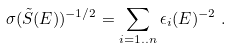Convert formula to latex. <formula><loc_0><loc_0><loc_500><loc_500>\sigma ( \tilde { S } ( E ) ) ^ { - 1 / 2 } = \sum _ { i = 1 . . n } \epsilon _ { i } ( E ) ^ { - 2 } \ .</formula> 